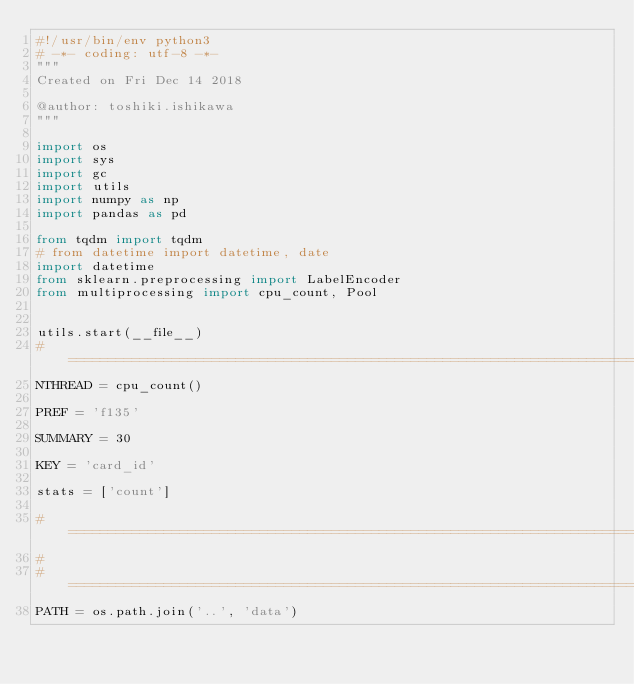Convert code to text. <code><loc_0><loc_0><loc_500><loc_500><_Python_>#!/usr/bin/env python3
# -*- coding: utf-8 -*-
"""
Created on Fri Dec 14 2018

@author: toshiki.ishikawa
"""

import os
import sys
import gc
import utils
import numpy as np
import pandas as pd

from tqdm import tqdm
# from datetime import datetime, date
import datetime
from sklearn.preprocessing import LabelEncoder
from multiprocessing import cpu_count, Pool


utils.start(__file__)
#==============================================================================
NTHREAD = cpu_count()

PREF = 'f135'

SUMMARY = 30

KEY = 'card_id'

stats = ['count']

# =============================================================================
#
# =============================================================================
PATH = os.path.join('..', 'data')
</code> 